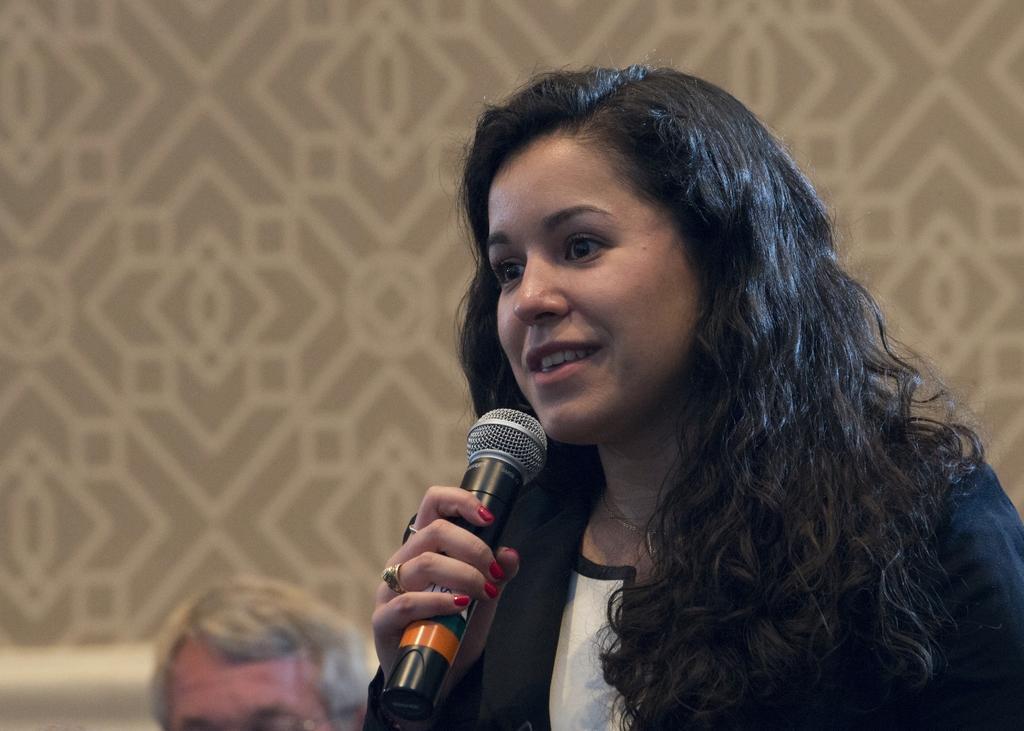Describe this image in one or two sentences. In this image the woman at the right side is holding a mic and is speaking since we see her mouth open. and in the background we see other person head and a painting on the wall. 